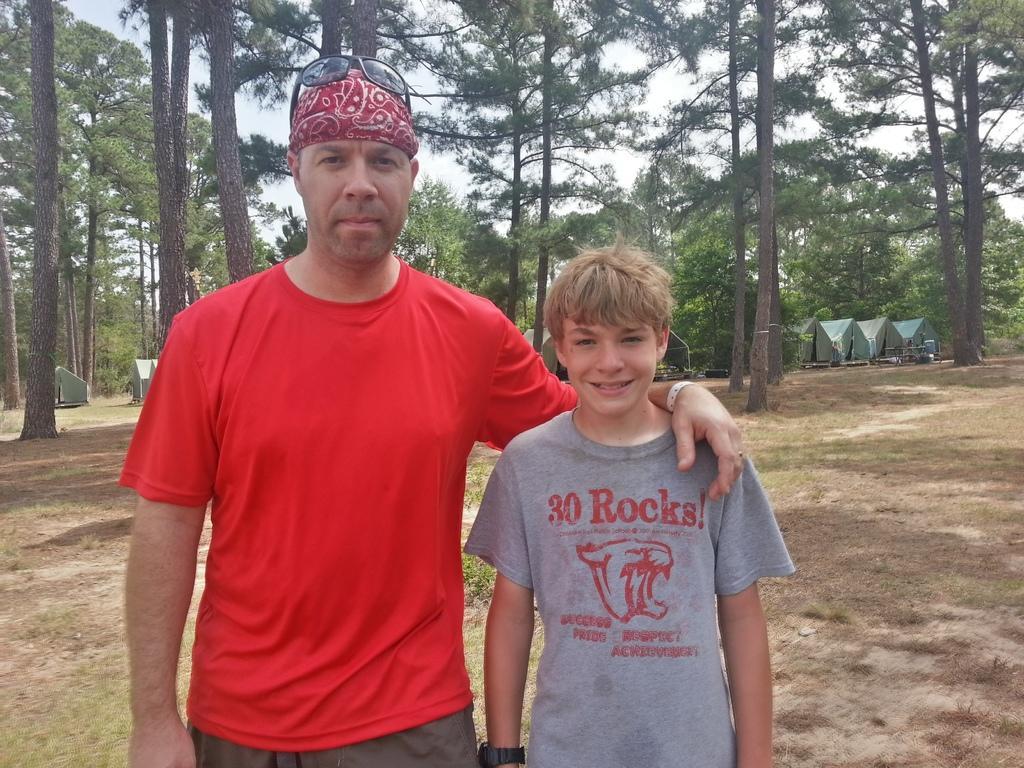In one or two sentences, can you explain what this image depicts? In the center of the image there are two people standing. In the background of the image there are trees. There are tents. At the bottom of the image there is grass. 